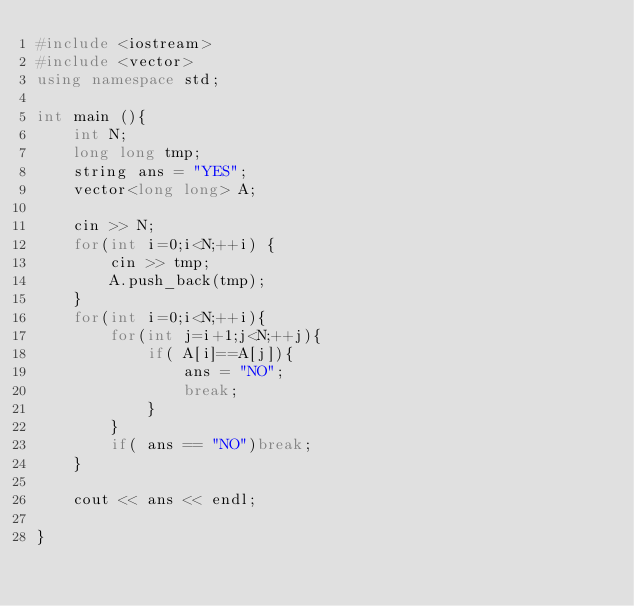<code> <loc_0><loc_0><loc_500><loc_500><_C++_>#include <iostream>
#include <vector>
using namespace std;

int main (){
    int N;
    long long tmp;
    string ans = "YES";
    vector<long long> A;
 
    cin >> N;
    for(int i=0;i<N;++i) {
        cin >> tmp;
        A.push_back(tmp);
    } 
    for(int i=0;i<N;++i){
        for(int j=i+1;j<N;++j){
            if( A[i]==A[j]){
                ans = "NO";
                break;
            }
        }
        if( ans == "NO")break;
    }

    cout << ans << endl;

}</code> 